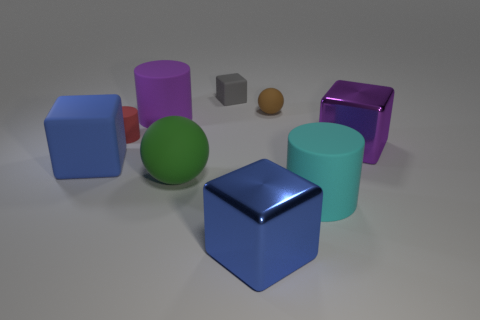What is the color of the tiny matte object that is the same shape as the large green object? brown 